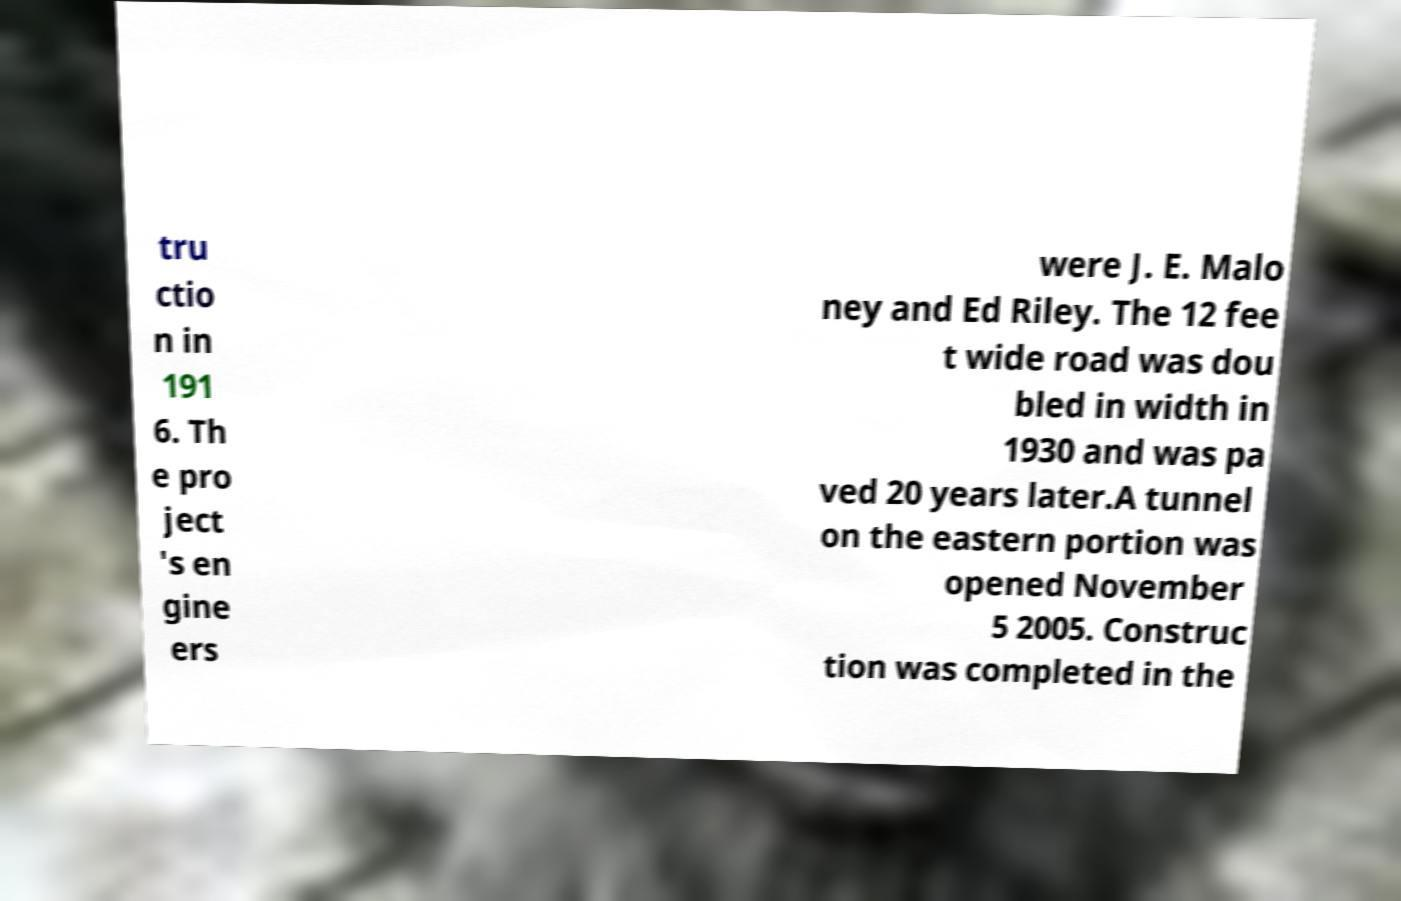Can you accurately transcribe the text from the provided image for me? tru ctio n in 191 6. Th e pro ject 's en gine ers were J. E. Malo ney and Ed Riley. The 12 fee t wide road was dou bled in width in 1930 and was pa ved 20 years later.A tunnel on the eastern portion was opened November 5 2005. Construc tion was completed in the 